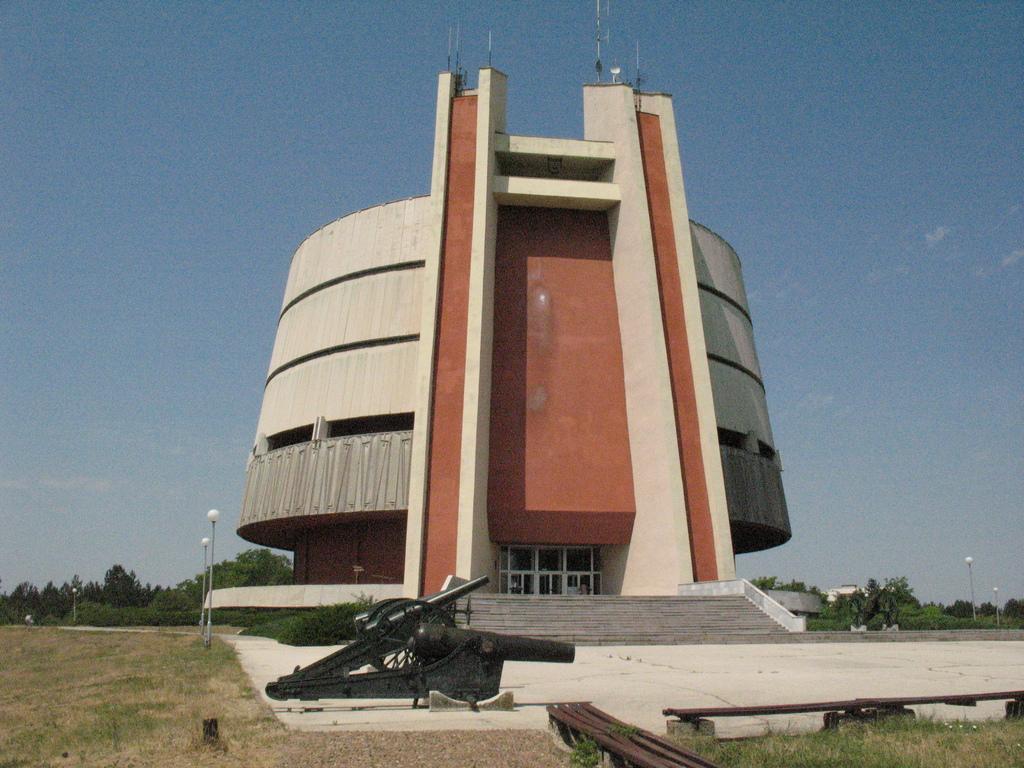Can you describe this image briefly? In this image we can see a building with windows and the staircase. We can also see the cannons on the ground, benches, grass, plants, a group of trees, street poles and the sky. 